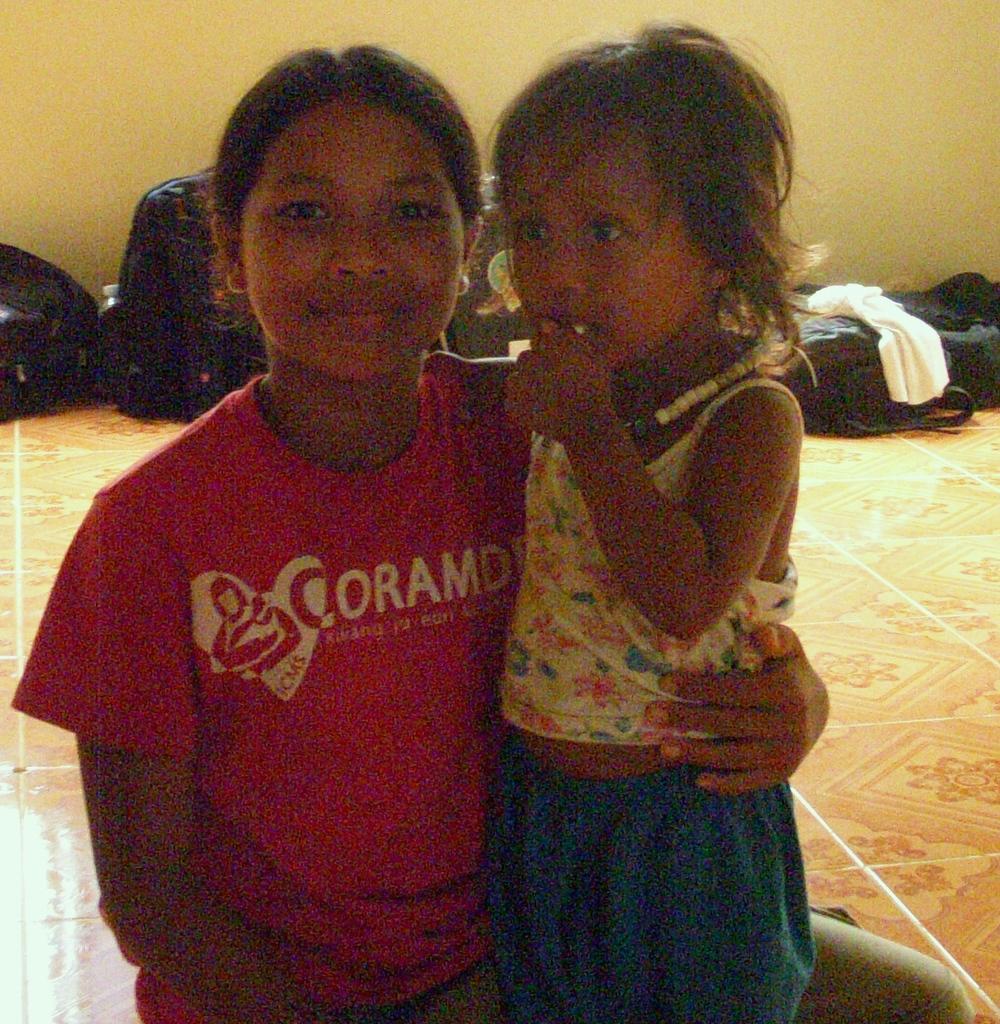Can you describe this image briefly? In this picture we can see two people on the floor and in the background we can see bags, clothes, wall. 